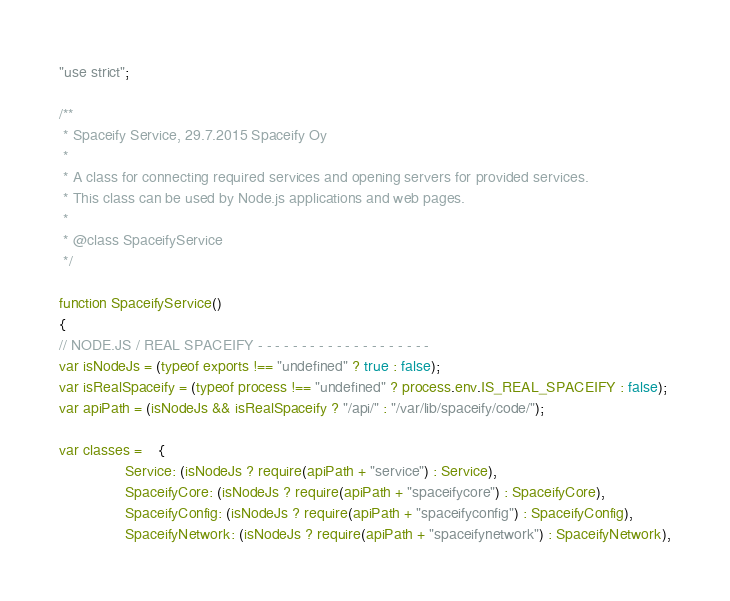<code> <loc_0><loc_0><loc_500><loc_500><_JavaScript_>"use strict";

/**
 * Spaceify Service, 29.7.2015 Spaceify Oy
 *
 * A class for connecting required services and opening servers for provided services.
 * This class can be used by Node.js applications and web pages.
 *
 * @class SpaceifyService
 */

function SpaceifyService()
{
// NODE.JS / REAL SPACEIFY - - - - - - - - - - - - - - - - - - - -
var isNodeJs = (typeof exports !== "undefined" ? true : false);
var isRealSpaceify = (typeof process !== "undefined" ? process.env.IS_REAL_SPACEIFY : false);
var apiPath = (isNodeJs && isRealSpaceify ? "/api/" : "/var/lib/spaceify/code/");

var classes = 	{
				Service: (isNodeJs ? require(apiPath + "service") : Service),
				SpaceifyCore: (isNodeJs ? require(apiPath + "spaceifycore") : SpaceifyCore),
				SpaceifyConfig: (isNodeJs ? require(apiPath + "spaceifyconfig") : SpaceifyConfig),
				SpaceifyNetwork: (isNodeJs ? require(apiPath + "spaceifynetwork") : SpaceifyNetwork),</code> 